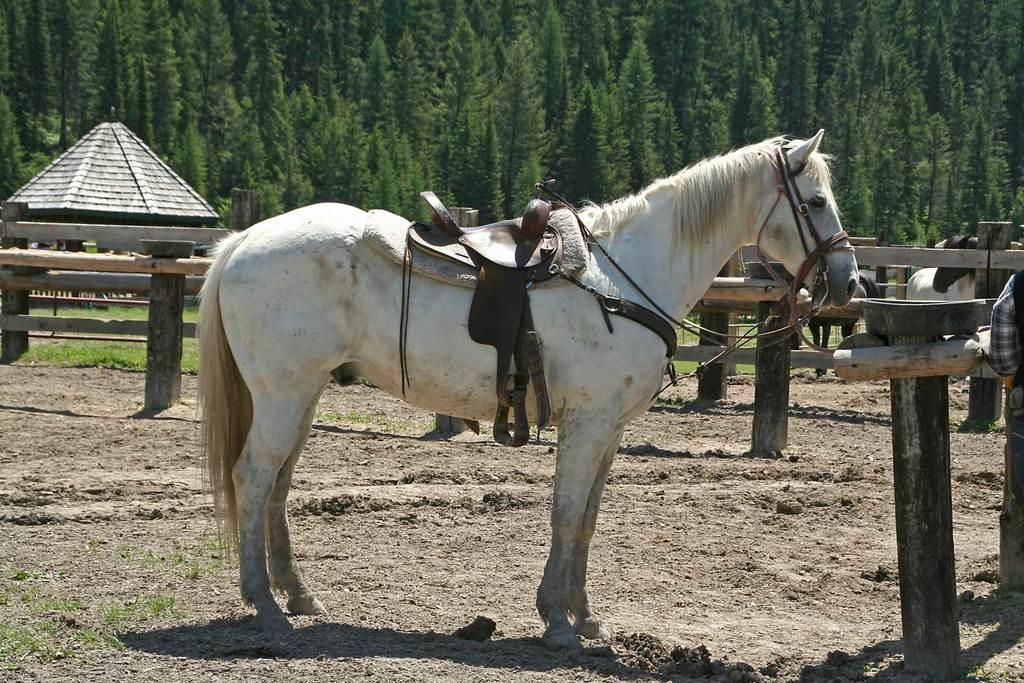What animal is the main subject of the image? There is a horse in the image. What equipment is attached to the horse? The horse has a stirrup and a noseband. What type of hobby does the horse have? The horse has a fender hobby. What is located behind the horse? There is a wooden fence behind the horse. What can be seen beyond the wooden fence? There are trees behind the wooden fence. How many snakes are slithering around the horse's legs in the image? There are no snakes present in the image; the horse is the main subject. What type of flock can be seen flying over the horse in the image? There are no birds or flocks visible in the image. 